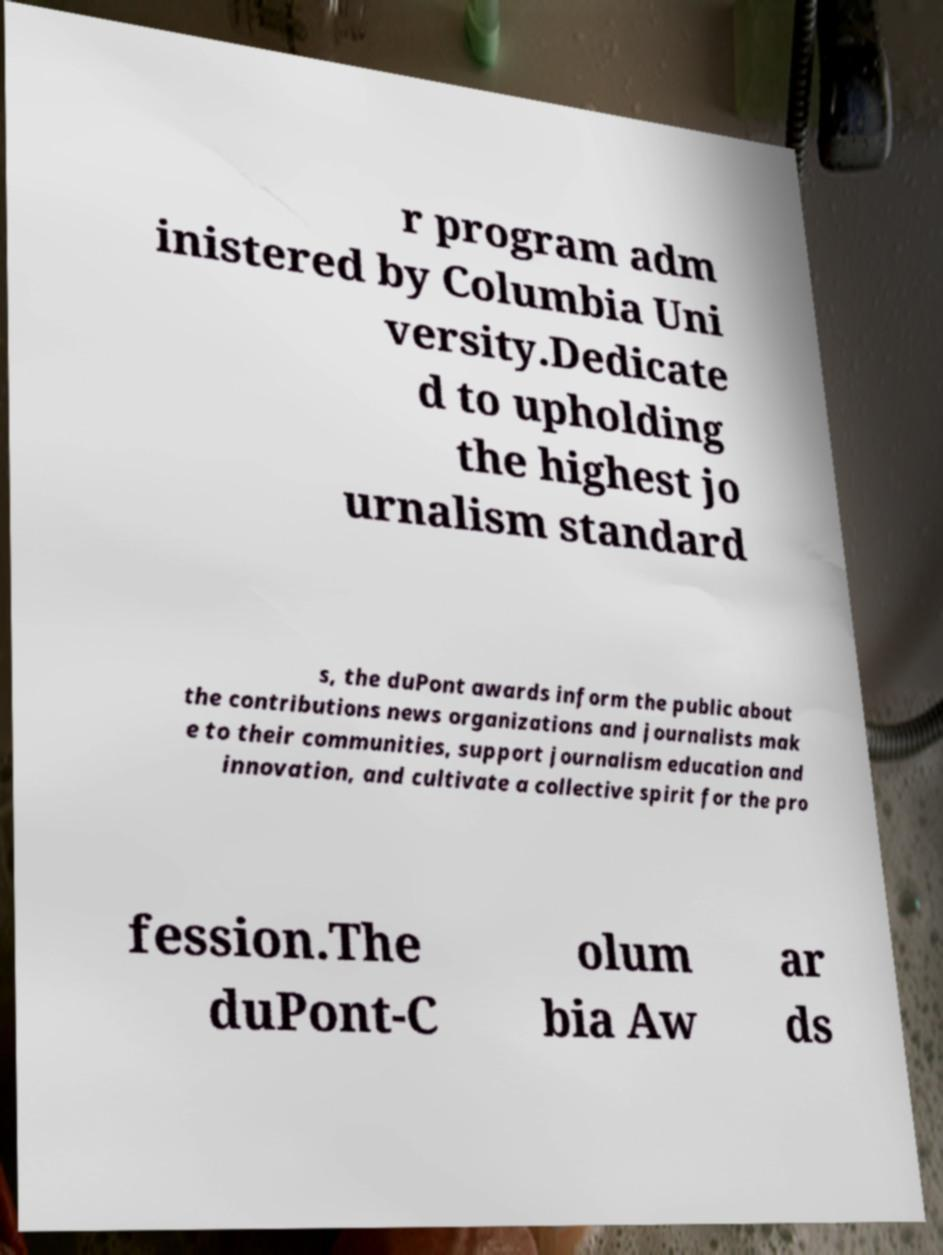For documentation purposes, I need the text within this image transcribed. Could you provide that? r program adm inistered by Columbia Uni versity.Dedicate d to upholding the highest jo urnalism standard s, the duPont awards inform the public about the contributions news organizations and journalists mak e to their communities, support journalism education and innovation, and cultivate a collective spirit for the pro fession.The duPont-C olum bia Aw ar ds 